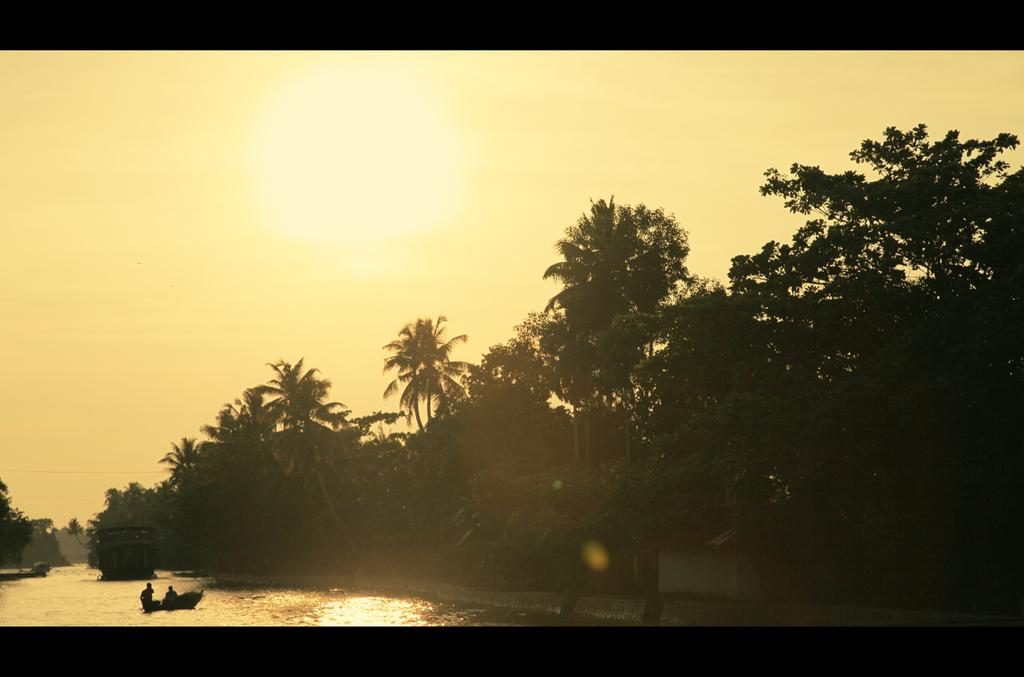What is the main feature of the image? The main feature of the image is a water surface. What is on the water surface? There is a boat on the water surface. What can be seen in the background of the image? Trees and the sky are visible in the image. Where is the horse standing in the image? There is no horse present in the image. What type of throne can be seen in the image? There is no throne present in the image. 